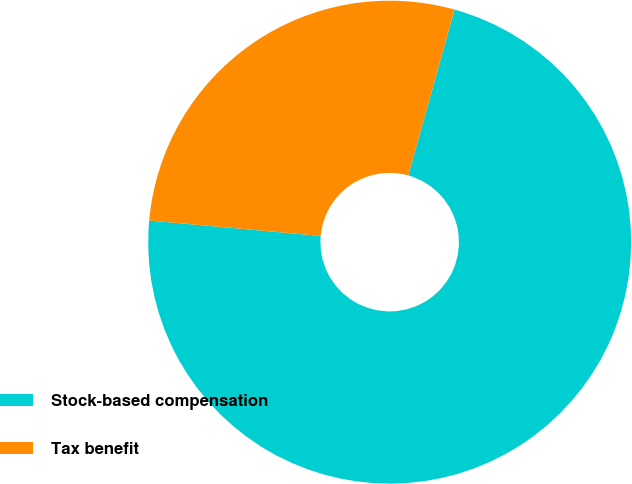<chart> <loc_0><loc_0><loc_500><loc_500><pie_chart><fcel>Stock-based compensation<fcel>Tax benefit<nl><fcel>72.1%<fcel>27.9%<nl></chart> 